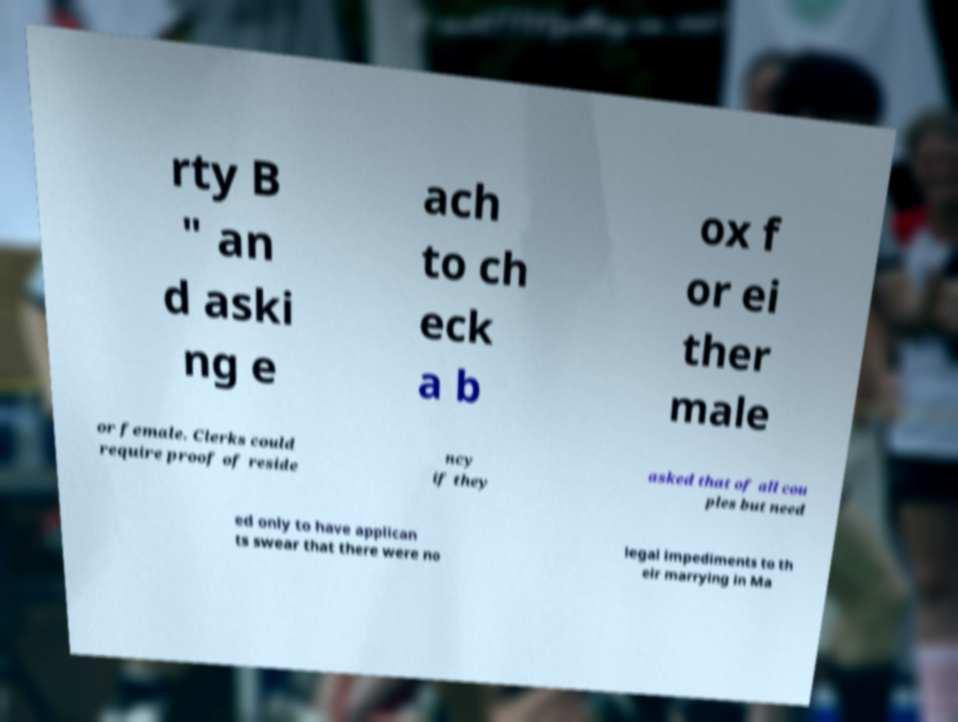I need the written content from this picture converted into text. Can you do that? rty B " an d aski ng e ach to ch eck a b ox f or ei ther male or female. Clerks could require proof of reside ncy if they asked that of all cou ples but need ed only to have applican ts swear that there were no legal impediments to th eir marrying in Ma 